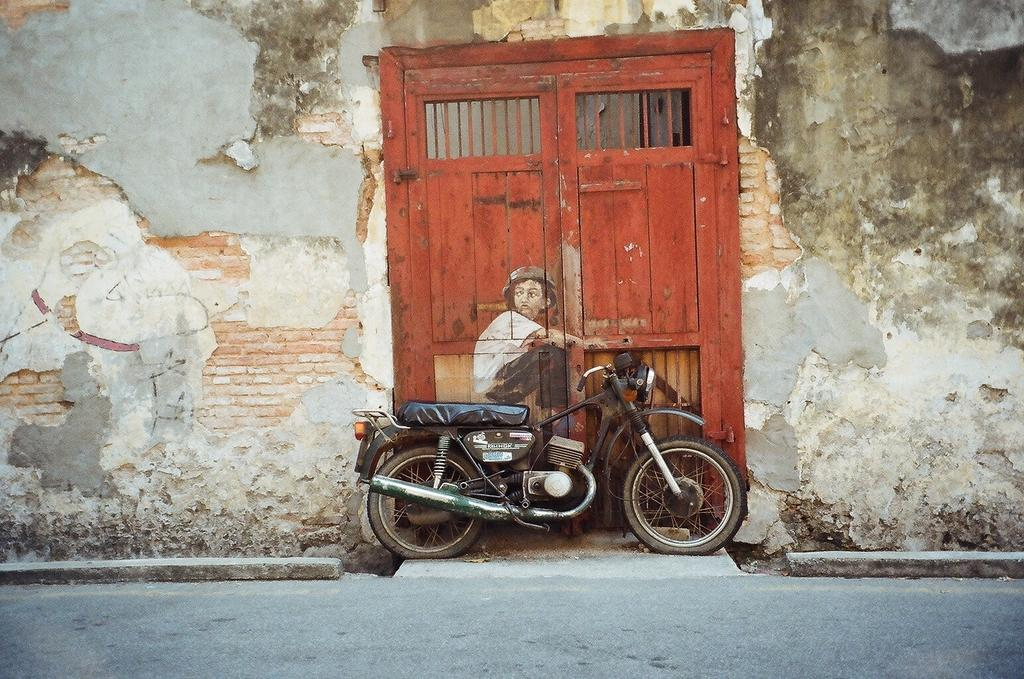What is placed on the ground in the image? There is a motorbike placed on the ground in the image. What can be seen in the background of the image? There is a wall in the image. Is there any entrance visible in the image? Yes, there is a door in the image. What is depicted on the door? The door has a painting of a person on it. What type of attraction can be seen in the alley during the day in the image? There is no alley or daytime setting depicted in the image, and no attraction is visible. 